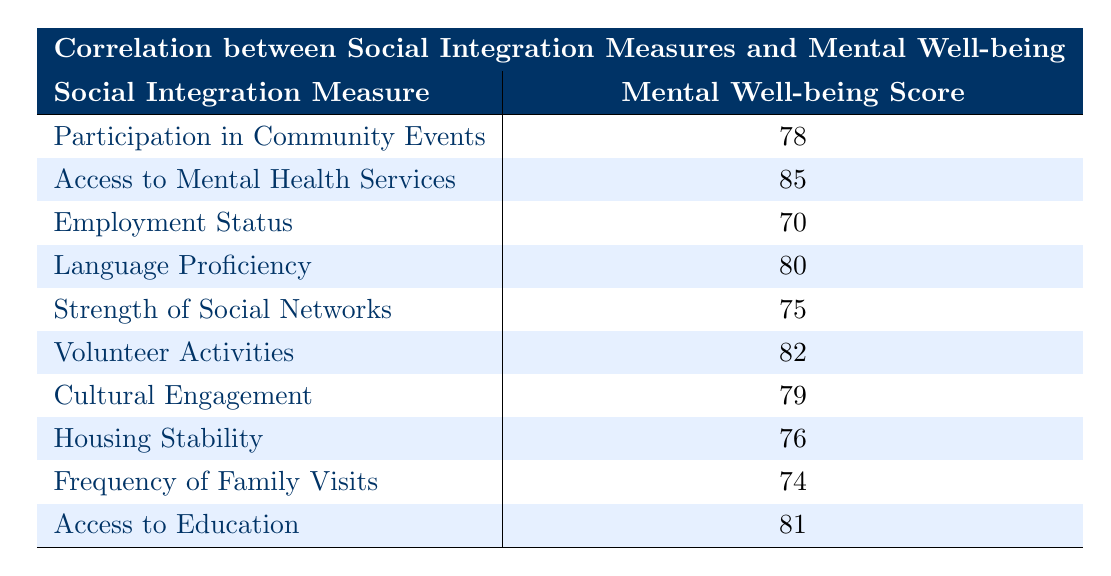What is the mental well-being score for Access to Mental Health Services? The score is directly provided in the table next to the social integration measure "Access to Mental Health Services". The mental well-being score listed is 85.
Answer: 85 What social integration measure corresponds to the lowest mental well-being score? The table lists various social integration measures along with their respective mental well-being scores. By comparing these scores, "Employment Status" has the lowest score at 70.
Answer: Employment Status What is the average mental well-being score of the measures related to community participation (Participation in Community Events, Volunteer Activities, and Cultural Engagement)? To find the average, first, sum the scores of the three measures: 78 (Participation in Community Events) + 82 (Volunteer Activities) + 79 (Cultural Engagement) = 239. Then divide by the number of measures, which is 3. The average score is 239/3 = 79.67.
Answer: 79.67 Is the mental well-being score for Language Proficiency higher than that for Frequency of Family Visits? The scores for Language Proficiency (80) and Frequency of Family Visits (74) are directly compared. Since 80 is greater than 74, the statement is true.
Answer: Yes How many social integration measures have a mental well-being score of 80 or higher? Checking the table, the scores of 80 or higher correspond to Access to Mental Health Services (85), Language Proficiency (80), Volunteer Activities (82), Access to Education (81), and Participation in Community Events (78), which totals 5 measures.
Answer: 5 What is the difference between the mental well-being scores for Housing Stability and Strength of Social Networks? The mental well-being score for Housing Stability is 76 and for Strength of Social Networks is 75. The difference is calculated as 76 - 75 = 1.
Answer: 1 Is it true that Cultural Engagement has a higher mental well-being score than Housing Stability? The scores are compared directly: Cultural Engagement = 79 and Housing Stability = 76. Since 79 is greater than 76, the assertion holds true.
Answer: Yes Which social integration measure has a mental well-being score closest to the average of all measures listed? First, calculate the average of all the scores (78, 85, 70, 80, 75, 82, 79, 76, 74, 81). The sum is 785, and the number of measures is 10. The average is 785/10 = 78.5. The closest score to 78.5 is Participation in Community Events (78), with a difference of 0.5.
Answer: Participation in Community Events 